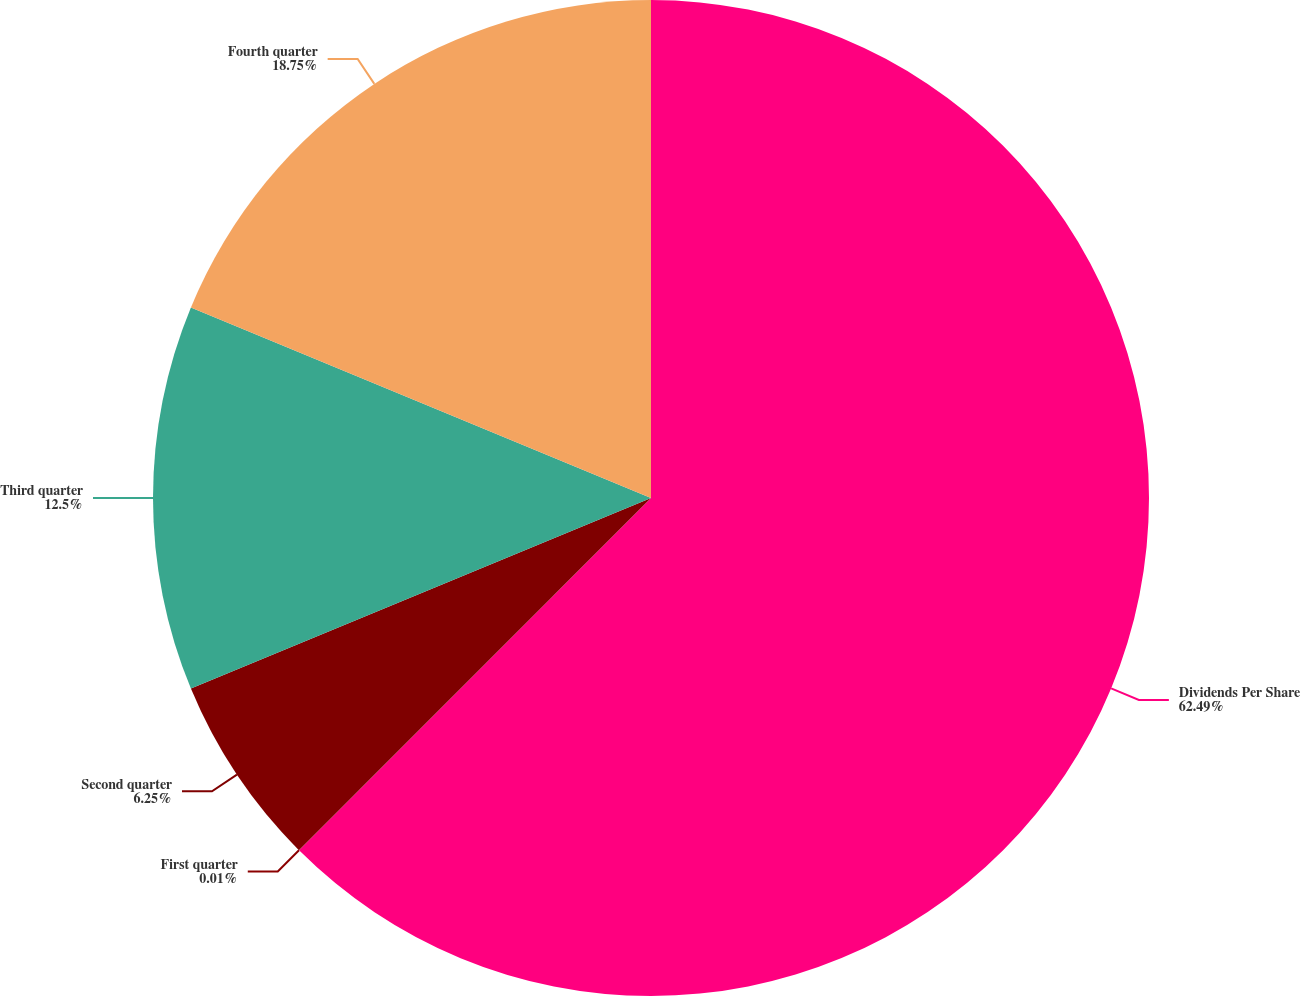Convert chart to OTSL. <chart><loc_0><loc_0><loc_500><loc_500><pie_chart><fcel>Dividends Per Share<fcel>First quarter<fcel>Second quarter<fcel>Third quarter<fcel>Fourth quarter<nl><fcel>62.49%<fcel>0.01%<fcel>6.25%<fcel>12.5%<fcel>18.75%<nl></chart> 